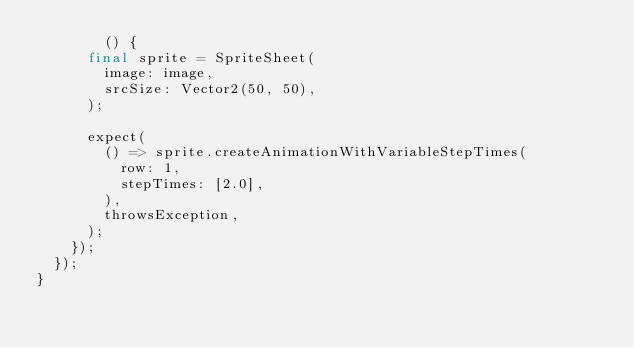Convert code to text. <code><loc_0><loc_0><loc_500><loc_500><_Dart_>        () {
      final sprite = SpriteSheet(
        image: image,
        srcSize: Vector2(50, 50),
      );

      expect(
        () => sprite.createAnimationWithVariableStepTimes(
          row: 1,
          stepTimes: [2.0],
        ),
        throwsException,
      );
    });
  });
}
</code> 